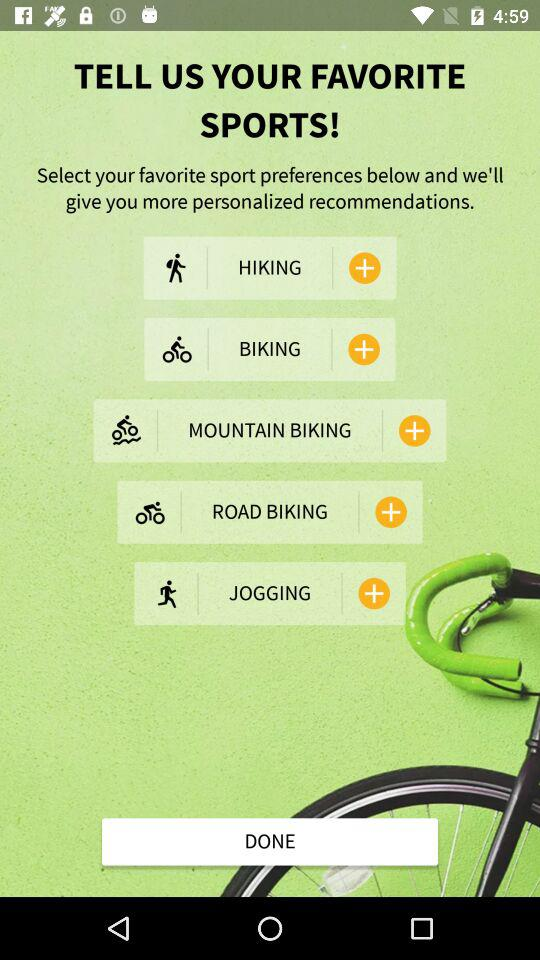How many sports options are there?
Answer the question using a single word or phrase. 5 